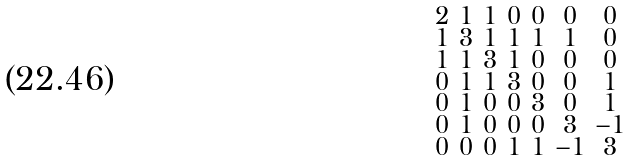<formula> <loc_0><loc_0><loc_500><loc_500>\begin{smallmatrix} 2 & 1 & 1 & 0 & 0 & 0 & 0 \\ 1 & 3 & 1 & 1 & 1 & 1 & 0 \\ 1 & 1 & 3 & 1 & 0 & 0 & 0 \\ 0 & 1 & 1 & 3 & 0 & 0 & 1 \\ 0 & 1 & 0 & 0 & 3 & 0 & 1 \\ 0 & 1 & 0 & 0 & 0 & 3 & - 1 \\ 0 & 0 & 0 & 1 & 1 & - 1 & 3 \end{smallmatrix}</formula> 